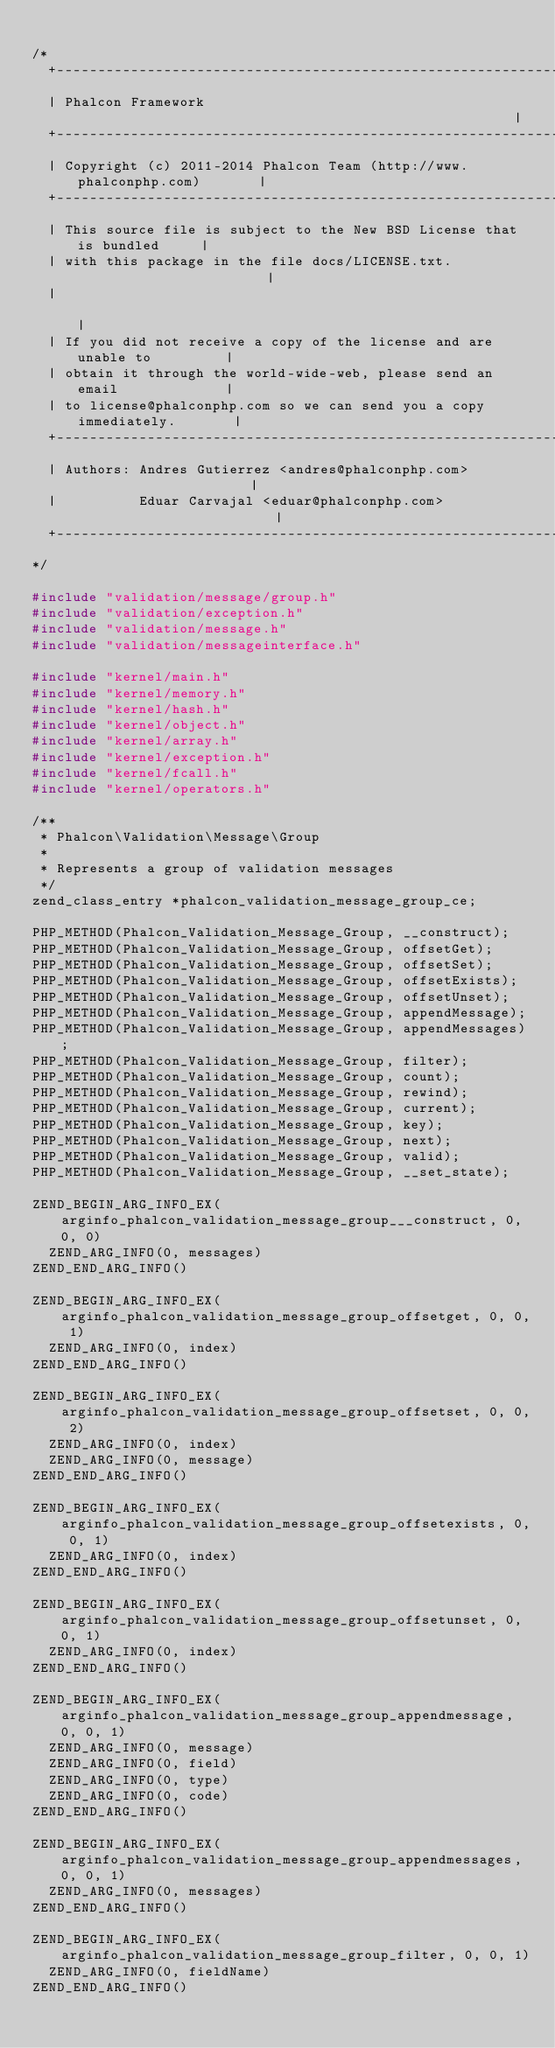Convert code to text. <code><loc_0><loc_0><loc_500><loc_500><_C_>
/*
  +------------------------------------------------------------------------+
  | Phalcon Framework                                                      |
  +------------------------------------------------------------------------+
  | Copyright (c) 2011-2014 Phalcon Team (http://www.phalconphp.com)       |
  +------------------------------------------------------------------------+
  | This source file is subject to the New BSD License that is bundled     |
  | with this package in the file docs/LICENSE.txt.                        |
  |                                                                        |
  | If you did not receive a copy of the license and are unable to         |
  | obtain it through the world-wide-web, please send an email             |
  | to license@phalconphp.com so we can send you a copy immediately.       |
  +------------------------------------------------------------------------+
  | Authors: Andres Gutierrez <andres@phalconphp.com>                      |
  |          Eduar Carvajal <eduar@phalconphp.com>                         |
  +------------------------------------------------------------------------+
*/

#include "validation/message/group.h"
#include "validation/exception.h"
#include "validation/message.h"
#include "validation/messageinterface.h"

#include "kernel/main.h"
#include "kernel/memory.h"
#include "kernel/hash.h"
#include "kernel/object.h"
#include "kernel/array.h"
#include "kernel/exception.h"
#include "kernel/fcall.h"
#include "kernel/operators.h"

/**
 * Phalcon\Validation\Message\Group
 *
 * Represents a group of validation messages
 */
zend_class_entry *phalcon_validation_message_group_ce;

PHP_METHOD(Phalcon_Validation_Message_Group, __construct);
PHP_METHOD(Phalcon_Validation_Message_Group, offsetGet);
PHP_METHOD(Phalcon_Validation_Message_Group, offsetSet);
PHP_METHOD(Phalcon_Validation_Message_Group, offsetExists);
PHP_METHOD(Phalcon_Validation_Message_Group, offsetUnset);
PHP_METHOD(Phalcon_Validation_Message_Group, appendMessage);
PHP_METHOD(Phalcon_Validation_Message_Group, appendMessages);
PHP_METHOD(Phalcon_Validation_Message_Group, filter);
PHP_METHOD(Phalcon_Validation_Message_Group, count);
PHP_METHOD(Phalcon_Validation_Message_Group, rewind);
PHP_METHOD(Phalcon_Validation_Message_Group, current);
PHP_METHOD(Phalcon_Validation_Message_Group, key);
PHP_METHOD(Phalcon_Validation_Message_Group, next);
PHP_METHOD(Phalcon_Validation_Message_Group, valid);
PHP_METHOD(Phalcon_Validation_Message_Group, __set_state);

ZEND_BEGIN_ARG_INFO_EX(arginfo_phalcon_validation_message_group___construct, 0, 0, 0)
	ZEND_ARG_INFO(0, messages)
ZEND_END_ARG_INFO()

ZEND_BEGIN_ARG_INFO_EX(arginfo_phalcon_validation_message_group_offsetget, 0, 0, 1)
	ZEND_ARG_INFO(0, index)
ZEND_END_ARG_INFO()

ZEND_BEGIN_ARG_INFO_EX(arginfo_phalcon_validation_message_group_offsetset, 0, 0, 2)
	ZEND_ARG_INFO(0, index)
	ZEND_ARG_INFO(0, message)
ZEND_END_ARG_INFO()

ZEND_BEGIN_ARG_INFO_EX(arginfo_phalcon_validation_message_group_offsetexists, 0, 0, 1)
	ZEND_ARG_INFO(0, index)
ZEND_END_ARG_INFO()

ZEND_BEGIN_ARG_INFO_EX(arginfo_phalcon_validation_message_group_offsetunset, 0, 0, 1)
	ZEND_ARG_INFO(0, index)
ZEND_END_ARG_INFO()

ZEND_BEGIN_ARG_INFO_EX(arginfo_phalcon_validation_message_group_appendmessage, 0, 0, 1)
	ZEND_ARG_INFO(0, message)
	ZEND_ARG_INFO(0, field)
	ZEND_ARG_INFO(0, type)
	ZEND_ARG_INFO(0, code)
ZEND_END_ARG_INFO()

ZEND_BEGIN_ARG_INFO_EX(arginfo_phalcon_validation_message_group_appendmessages, 0, 0, 1)
	ZEND_ARG_INFO(0, messages)
ZEND_END_ARG_INFO()

ZEND_BEGIN_ARG_INFO_EX(arginfo_phalcon_validation_message_group_filter, 0, 0, 1)
	ZEND_ARG_INFO(0, fieldName)
ZEND_END_ARG_INFO()
</code> 